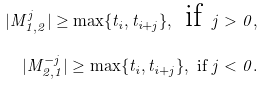Convert formula to latex. <formula><loc_0><loc_0><loc_500><loc_500>| M ^ { j } _ { 1 , 2 } | \geq \max \{ t _ { i } , t _ { i + j } \} , \text { if } j > 0 , \\ | M ^ { - j } _ { 2 , 1 } | \geq \max \{ t _ { i } , t _ { i + j } \} , \text { if } j < 0 .</formula> 